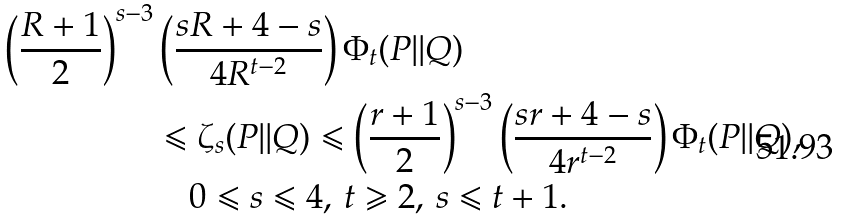<formula> <loc_0><loc_0><loc_500><loc_500>\left ( { \frac { R + 1 } { 2 } } \right ) ^ { s - 3 } & \left ( \frac { s R + 4 - s } { 4 R ^ { t - 2 } } \right ) \Phi _ { t } ( P | | Q ) \\ & \leqslant \zeta _ { s } ( P | | Q ) \leqslant \left ( { \frac { r + 1 } { 2 } } \right ) ^ { s - 3 } \left ( \frac { s r + 4 - s } { 4 r ^ { t - 2 } } \right ) \Phi _ { t } ( P | | Q ) , \\ & \quad 0 \leqslant s \leqslant 4 , \, t \geqslant 2 , \, s \leqslant t + 1 .</formula> 